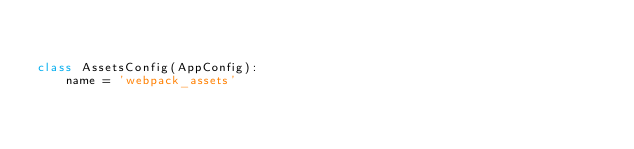<code> <loc_0><loc_0><loc_500><loc_500><_Python_>

class AssetsConfig(AppConfig):
    name = 'webpack_assets'
</code> 